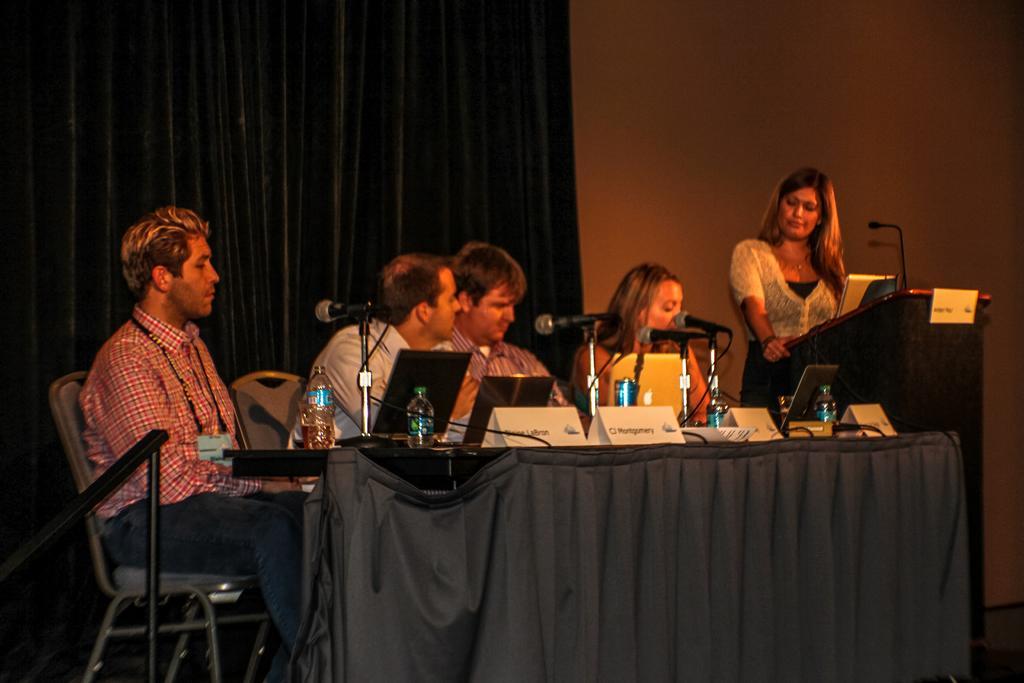Could you give a brief overview of what you see in this image? In this picture I can see a table in front, on which there are laptops, mics, water bottles, wires and name boards and behind the table I can see 3 men and a woman sitting on chairs. On the right side of this picture I can see a podium on which there is a mic and I see a woman behind the podium. In the background I can see the wall and the curtains. 